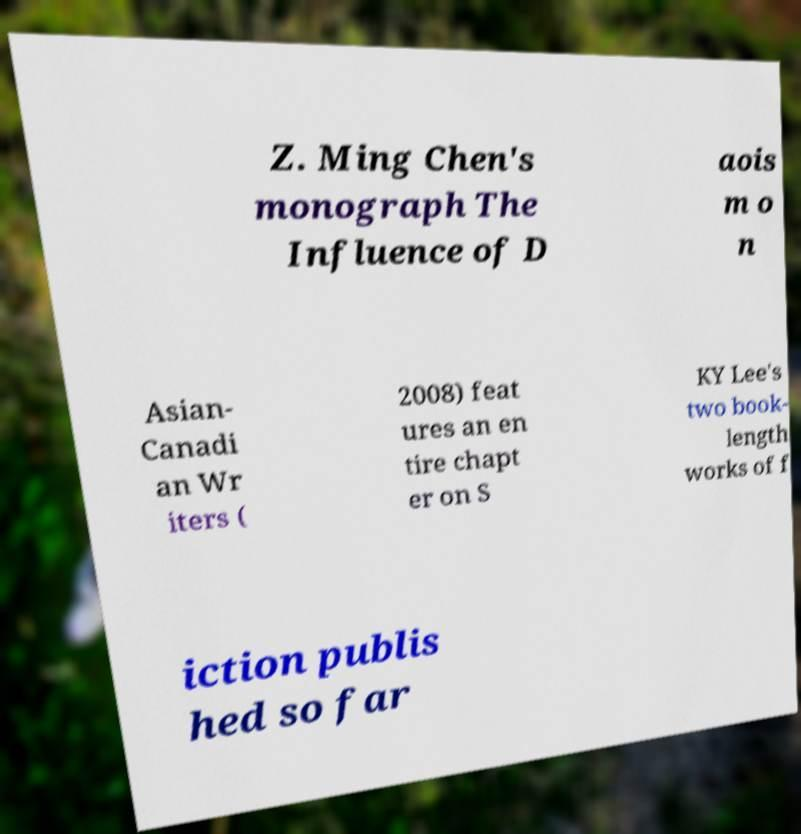I need the written content from this picture converted into text. Can you do that? Z. Ming Chen's monograph The Influence of D aois m o n Asian- Canadi an Wr iters ( 2008) feat ures an en tire chapt er on S KY Lee's two book- length works of f iction publis hed so far 